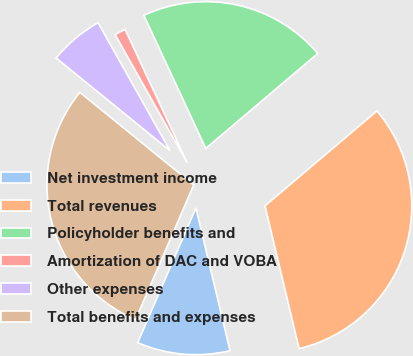<chart> <loc_0><loc_0><loc_500><loc_500><pie_chart><fcel>Net investment income<fcel>Total revenues<fcel>Policyholder benefits and<fcel>Amortization of DAC and VOBA<fcel>Other expenses<fcel>Total benefits and expenses<nl><fcel>10.22%<fcel>32.46%<fcel>20.74%<fcel>1.22%<fcel>5.98%<fcel>29.38%<nl></chart> 